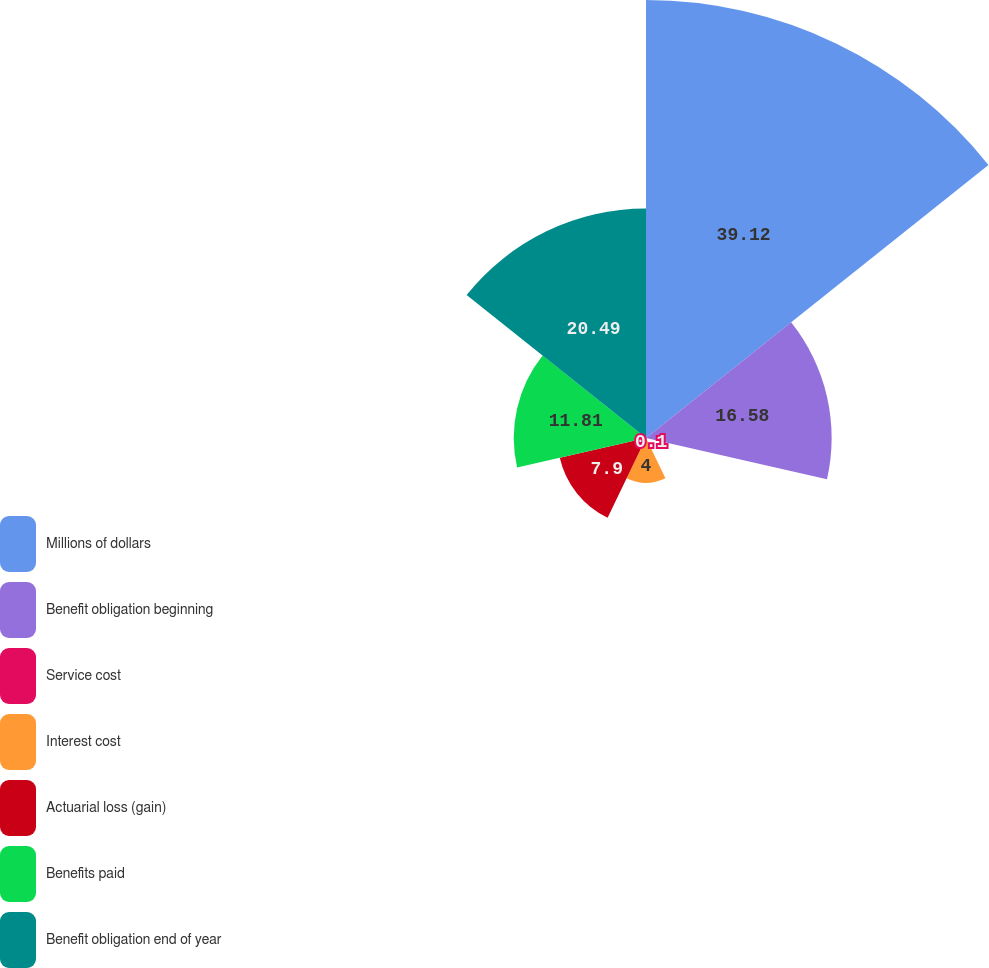<chart> <loc_0><loc_0><loc_500><loc_500><pie_chart><fcel>Millions of dollars<fcel>Benefit obligation beginning<fcel>Service cost<fcel>Interest cost<fcel>Actuarial loss (gain)<fcel>Benefits paid<fcel>Benefit obligation end of year<nl><fcel>39.12%<fcel>16.58%<fcel>0.1%<fcel>4.0%<fcel>7.9%<fcel>11.81%<fcel>20.49%<nl></chart> 